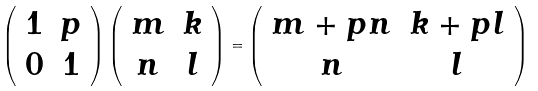<formula> <loc_0><loc_0><loc_500><loc_500>\left ( \begin{array} { c c } 1 & p \\ 0 & 1 \end{array} \right ) \left ( \begin{array} { c c } m & k \\ n & l \end{array} \right ) = \left ( \begin{array} { c c } m + p n & k + p l \\ n & l \end{array} \right )</formula> 